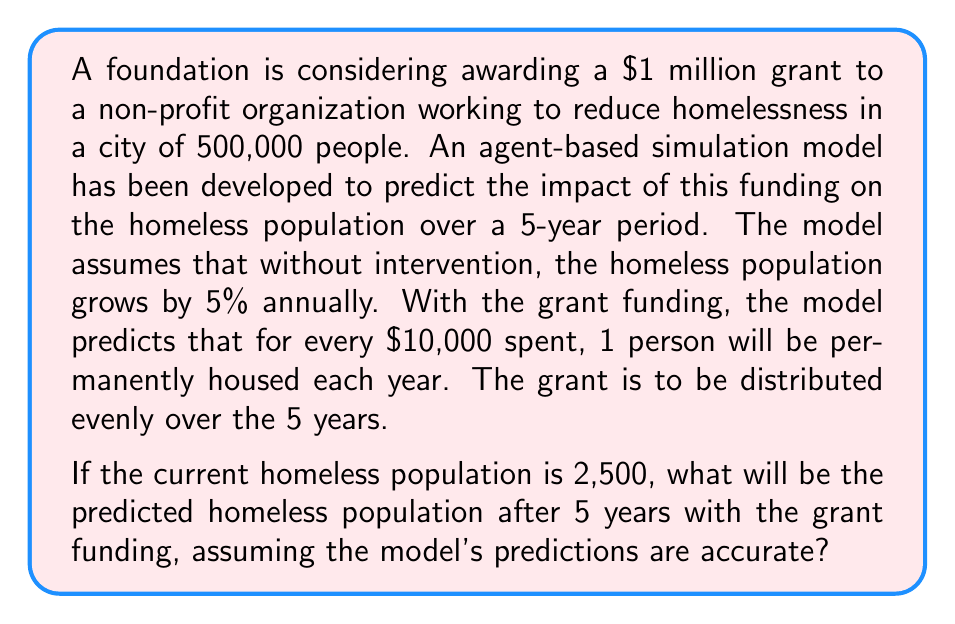Teach me how to tackle this problem. Let's approach this step-by-step:

1. Calculate the annual grant distribution:
   $$\text{Annual grant} = \frac{\$1,000,000}{5 \text{ years}} = \$200,000 \text{ per year}$$

2. Calculate the number of people housed per year due to the grant:
   $$\text{People housed annually} = \frac{\$200,000}{\$10,000 \text{ per person}} = 20 \text{ people}$$

3. Set up a recursive formula for the homeless population each year:
   Let $H_n$ be the homeless population in year $n$.
   $$H_{n+1} = 1.05H_n - 20$$
   This accounts for the 5% growth and 20 people housed each year.

4. Calculate the homeless population for each year:
   Year 0 (initial): $H_0 = 2,500$
   Year 1: $H_1 = 1.05(2,500) - 20 = 2,605$
   Year 2: $H_2 = 1.05(2,605) - 20 = 2,715.25$
   Year 3: $H_3 = 1.05(2,715.25) - 20 = 2,831.0125$
   Year 4: $H_4 = 1.05(2,831.0125) - 20 = 2,952.563125$
   Year 5: $H_5 = 1.05(2,952.563125) - 20 = 3,080.19128125$

5. Round the final result to the nearest whole number, as we can't have a fractional number of homeless people.
Answer: 3,080 people 